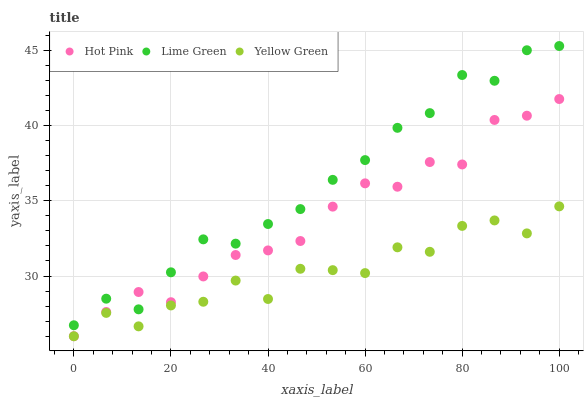Does Yellow Green have the minimum area under the curve?
Answer yes or no. Yes. Does Lime Green have the maximum area under the curve?
Answer yes or no. Yes. Does Lime Green have the minimum area under the curve?
Answer yes or no. No. Does Yellow Green have the maximum area under the curve?
Answer yes or no. No. Is Hot Pink the smoothest?
Answer yes or no. Yes. Is Yellow Green the roughest?
Answer yes or no. Yes. Is Lime Green the smoothest?
Answer yes or no. No. Is Lime Green the roughest?
Answer yes or no. No. Does Hot Pink have the lowest value?
Answer yes or no. Yes. Does Lime Green have the lowest value?
Answer yes or no. No. Does Lime Green have the highest value?
Answer yes or no. Yes. Does Yellow Green have the highest value?
Answer yes or no. No. Is Yellow Green less than Lime Green?
Answer yes or no. Yes. Is Lime Green greater than Yellow Green?
Answer yes or no. Yes. Does Hot Pink intersect Lime Green?
Answer yes or no. Yes. Is Hot Pink less than Lime Green?
Answer yes or no. No. Is Hot Pink greater than Lime Green?
Answer yes or no. No. Does Yellow Green intersect Lime Green?
Answer yes or no. No. 